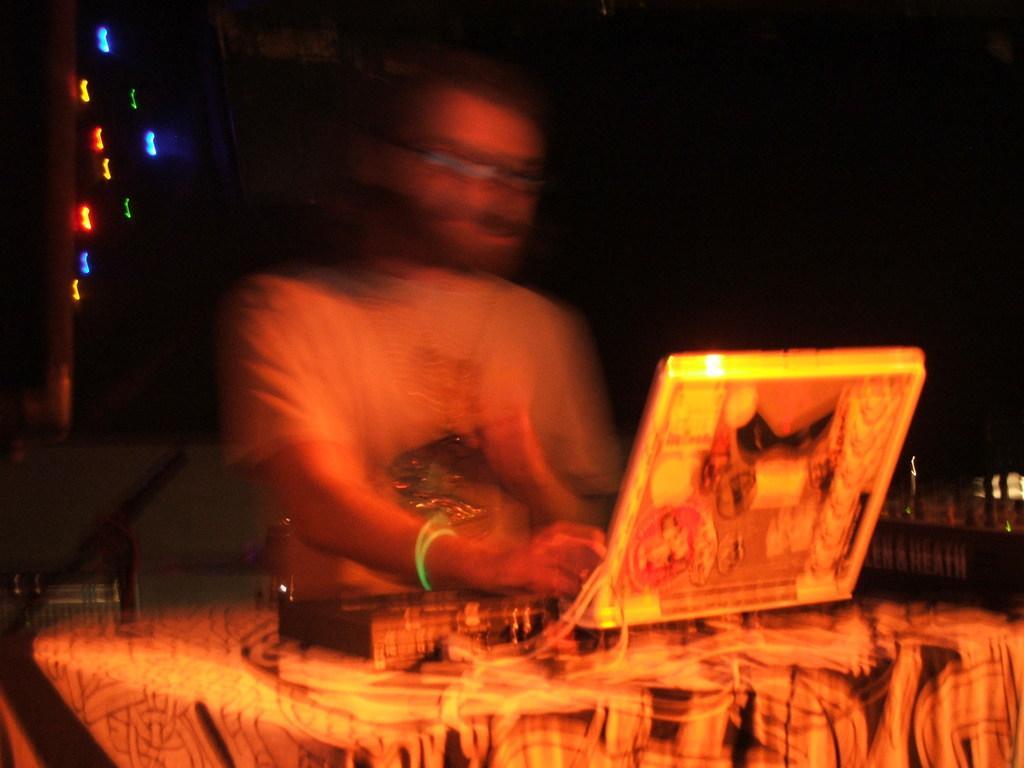Please provide a concise description of this image. In this picture we can observe a laptop placed on the table. There is a person standing in front of the laptop. He is wearing a T shirt. On the left side we can observe different colors of lights. The background is completely dark. 